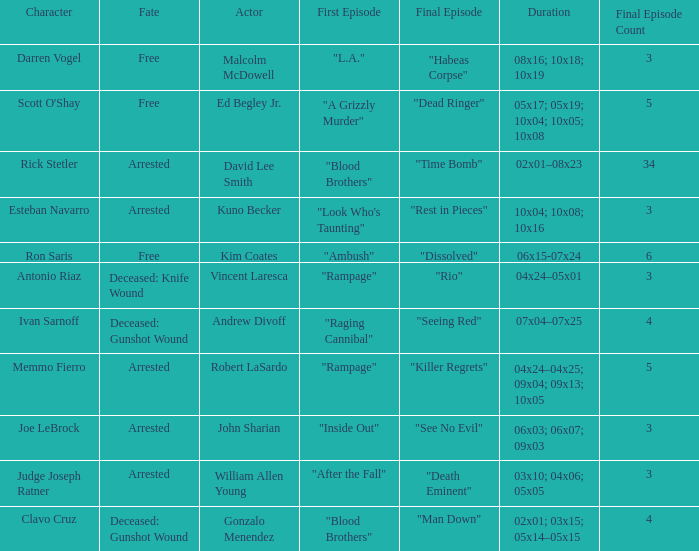What's the first epbeingode with final epbeingode being "rio" "Rampage". 